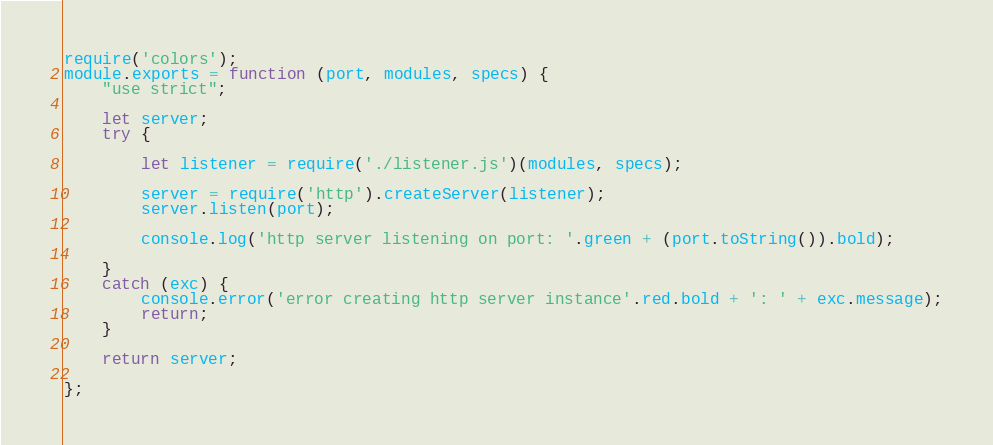<code> <loc_0><loc_0><loc_500><loc_500><_JavaScript_>require('colors');
module.exports = function (port, modules, specs) {
    "use strict";

    let server;
    try {

        let listener = require('./listener.js')(modules, specs);

        server = require('http').createServer(listener);
        server.listen(port);

        console.log('http server listening on port: '.green + (port.toString()).bold);

    }
    catch (exc) {
        console.error('error creating http server instance'.red.bold + ': ' + exc.message);
        return;
    }

    return server;

};
</code> 